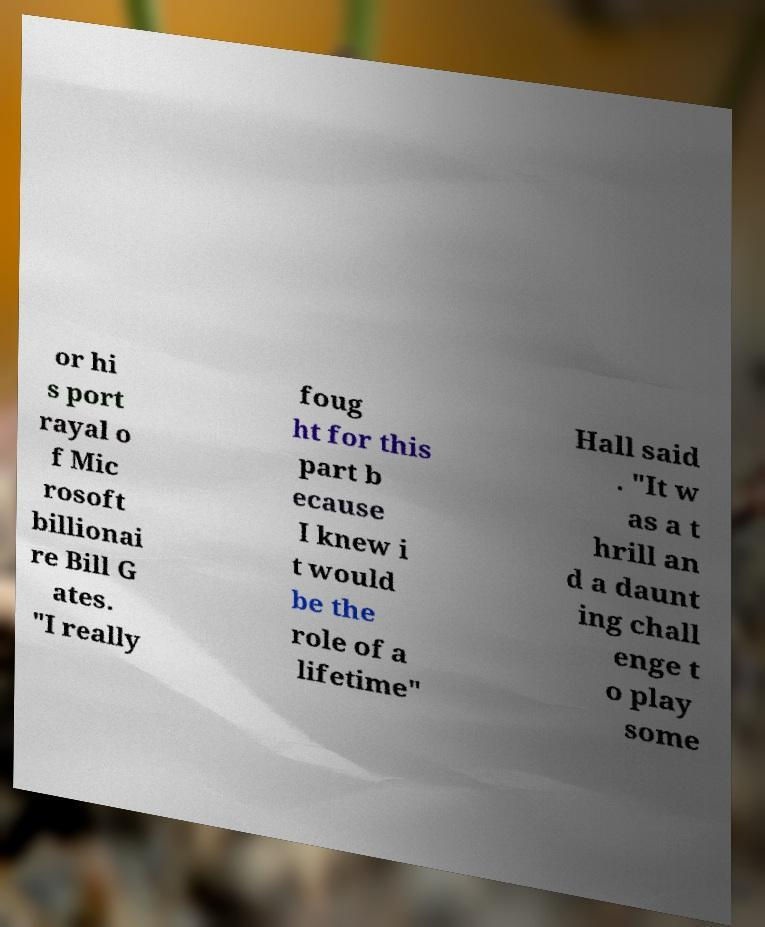I need the written content from this picture converted into text. Can you do that? or hi s port rayal o f Mic rosoft billionai re Bill G ates. "I really foug ht for this part b ecause I knew i t would be the role of a lifetime" Hall said . "It w as a t hrill an d a daunt ing chall enge t o play some 